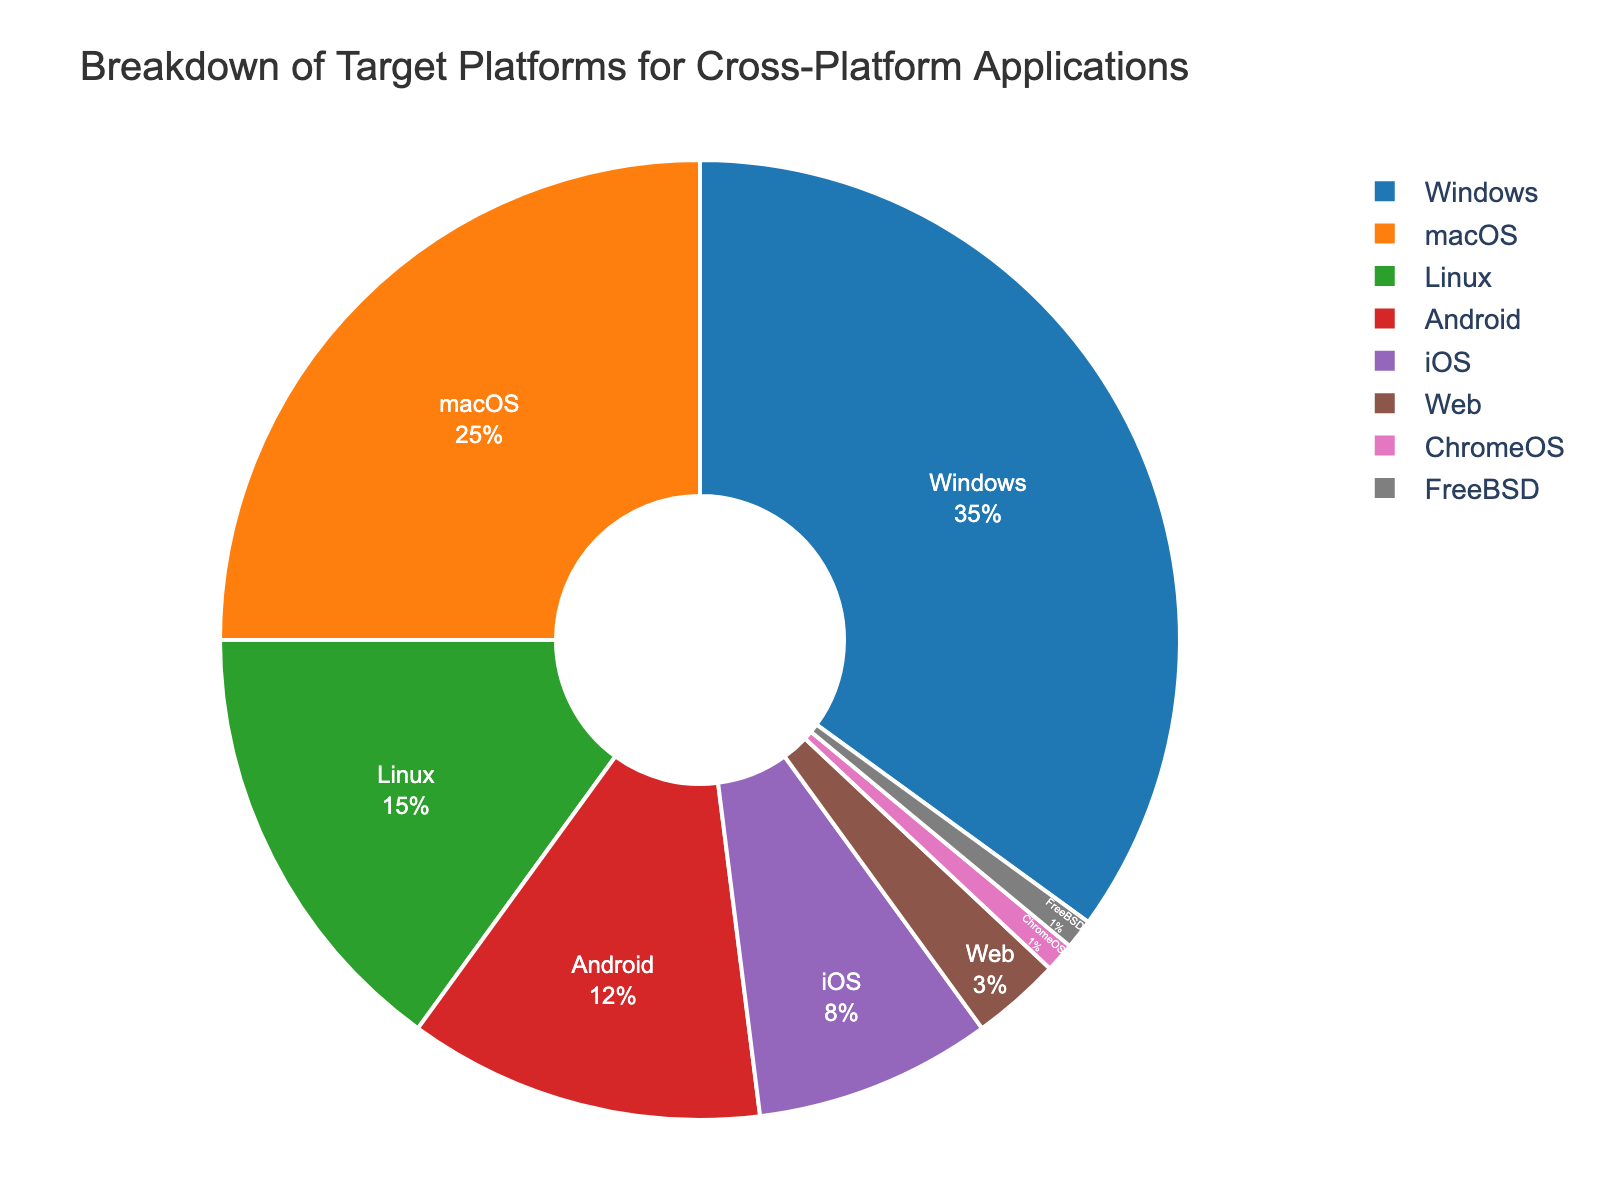Which platform has the largest share in the pie chart? The platform with the largest share is the one occupying the largest section in the pie chart. From the figure, Windows has the largest share.
Answer: Windows Which two platforms together have a smaller percentage than Windows alone? Windows has 35%. The two platforms with the smallest shares are ChromeOS (1%) and FreeBSD (1%), which together total 2%, much smaller than Windows alone.
Answer: ChromeOS and FreeBSD How many platforms have a percentage greater than or equal to 10%? By looking at the pie chart, we count the segments with percentages greater than or equal to 10%. These platforms are Windows (35%), macOS (25%), Linux (15%), and Android (12%). So, there are four such platforms.
Answer: 4 What is the combined percentage of all mobile platforms (Android and iOS)? Android has 12% and iOS has 8%. Adding these together: 12% + 8% = 20%.
Answer: 20% Which platform is represented by the smallest section of the pie chart? The platform with the smallest section in the pie chart corresponds to the one with the smallest percentage, which is 1%. Both ChromeOS and FreeBSD have 1%, but the smallest labeled section visually is ChromeOS.
Answer: ChromeOS How much more percentage does macOS have compared to Linux? macOS has 25% and Linux has 15%. Subtracting Linux's percentage from macOS's percentage: 25% - 15% = 10%.
Answer: 10% What is the combined share of all non-desktop platforms (Android, iOS, Web, ChromeOS, FreeBSD)? Adding the percentages of Android (12%), iOS (8%), Web (3%), ChromeOS (1%), and FreeBSD (1%): 12% + 8% + 3% + 1% + 1% = 25%.
Answer: 25% Which platform has the highest percentage after Windows and macOS? The platform with the highest percentage after Windows (35%) and macOS (25%) is Linux, which has 15%.
Answer: Linux Compare the share of Web and ChromeOS platforms. The Web platform has 3%, while ChromeOS has 1%. Comparing them, Web has a larger share than ChromeOS.
Answer: Web Is the percentage of Linux greater than the sum of ChromeOS and FreeBSD? Linux has 15%. The sum of ChromeOS (1%) and FreeBSD (1%) is 2%. Since 15% is greater than 2%, Linux's percentage is indeed greater.
Answer: Yes 